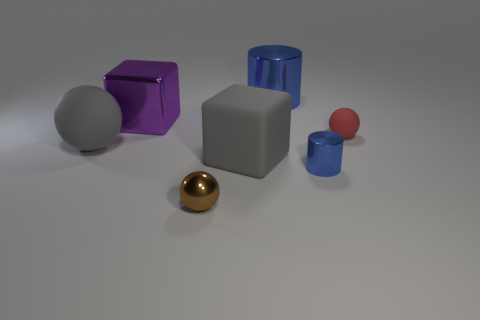Add 2 purple objects. How many objects exist? 9 Subtract all cylinders. How many objects are left? 5 Add 2 gray spheres. How many gray spheres exist? 3 Subtract 2 blue cylinders. How many objects are left? 5 Subtract all brown cylinders. Subtract all tiny red balls. How many objects are left? 6 Add 4 large cylinders. How many large cylinders are left? 5 